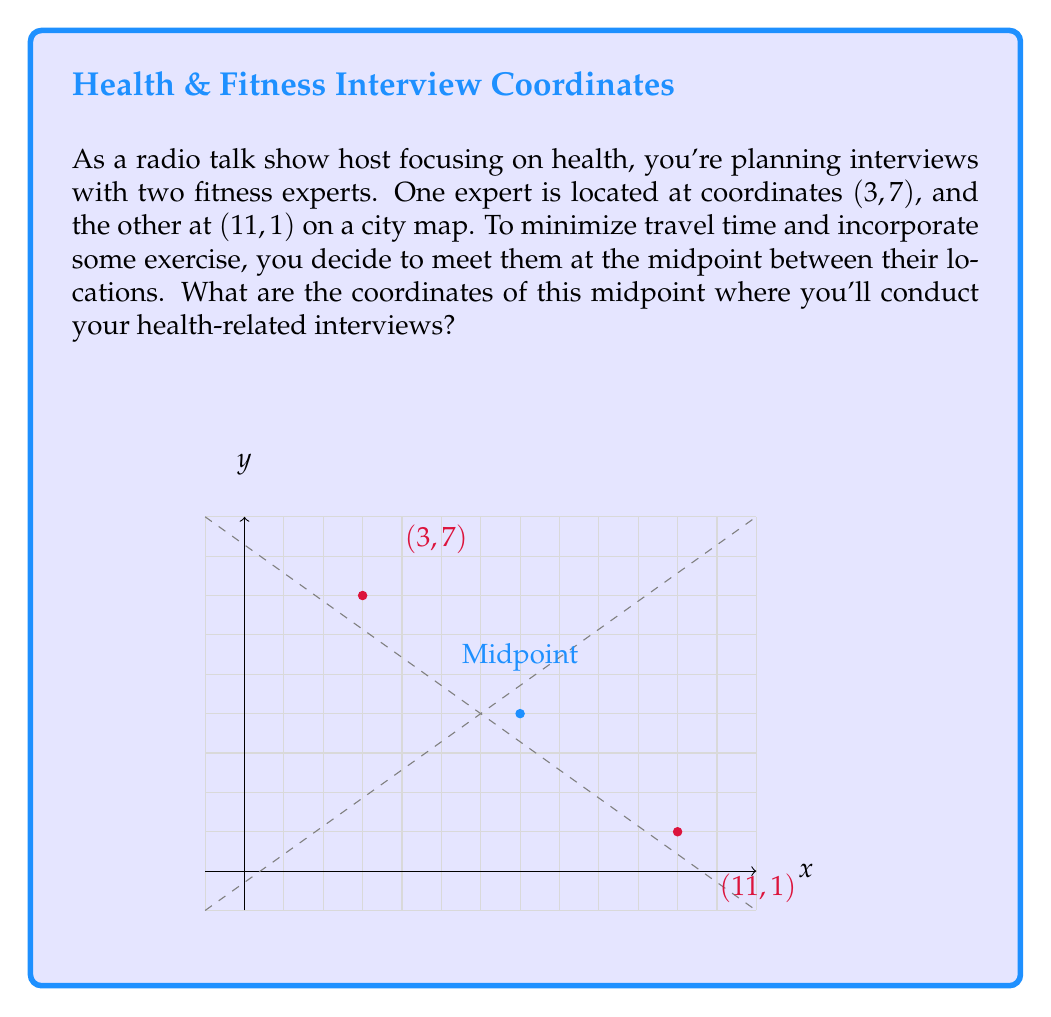Provide a solution to this math problem. To find the midpoint between two points, we use the midpoint formula:

$$ \text{Midpoint} = \left(\frac{x_1 + x_2}{2}, \frac{y_1 + y_2}{2}\right) $$

Where $(x_1, y_1)$ is the first point and $(x_2, y_2)$ is the second point.

Given:
- First point (Expert 1): $(3, 7)$
- Second point (Expert 2): $(11, 1)$

Step 1: Calculate the x-coordinate of the midpoint:
$$ x = \frac{x_1 + x_2}{2} = \frac{3 + 11}{2} = \frac{14}{2} = 7 $$

Step 2: Calculate the y-coordinate of the midpoint:
$$ y = \frac{y_1 + y_2}{2} = \frac{7 + 1}{2} = \frac{8}{2} = 4 $$

Therefore, the midpoint coordinates are $(7, 4)$.
Answer: (7, 4) 